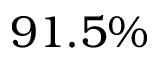<formula> <loc_0><loc_0><loc_500><loc_500>9 1 . 5 \%</formula> 